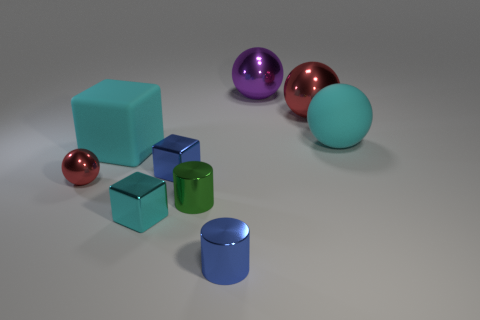Subtract all cyan cubes. How many were subtracted if there are1cyan cubes left? 1 Subtract 1 balls. How many balls are left? 3 Add 1 blue cylinders. How many objects exist? 10 Subtract all shiny spheres. How many spheres are left? 1 Subtract all green balls. Subtract all purple cubes. How many balls are left? 4 Subtract all spheres. How many objects are left? 5 Add 5 metallic cylinders. How many metallic cylinders exist? 7 Subtract 1 purple spheres. How many objects are left? 8 Subtract all tiny green metal things. Subtract all large red metal objects. How many objects are left? 7 Add 5 purple spheres. How many purple spheres are left? 6 